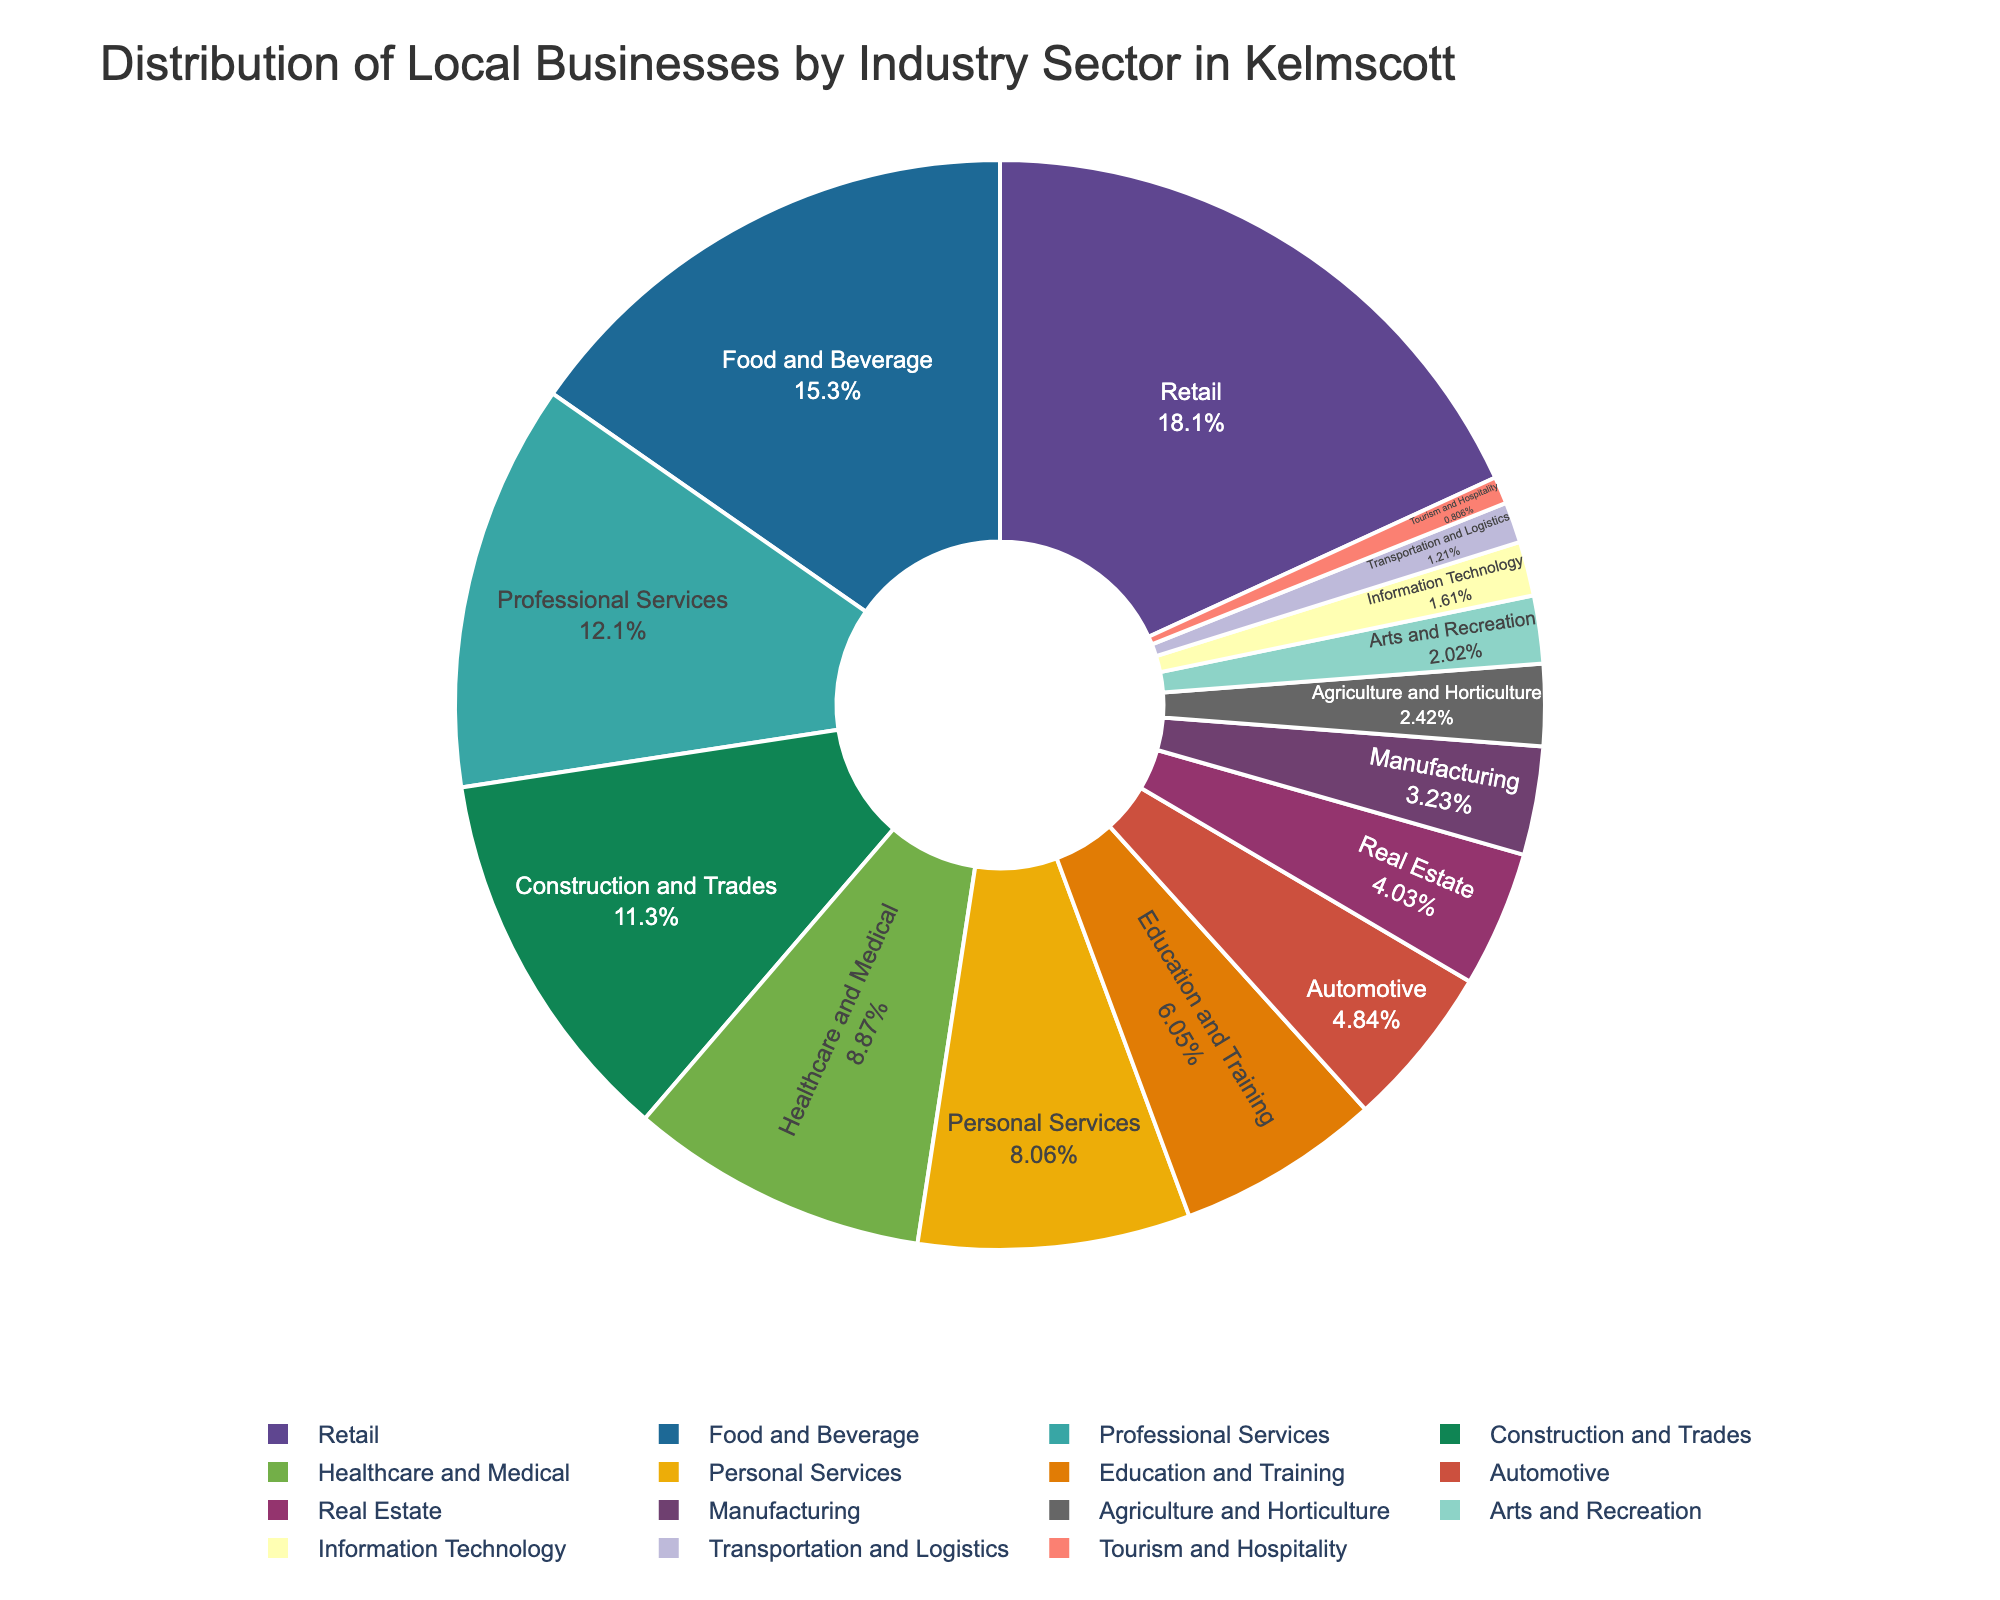What's the most common industry sector for local businesses in Kelmscott? Looking at the pie chart, we can see which sector occupies the largest portion. "Retail" is visually the largest segment.
Answer: Retail Which industry sector has fewer businesses: Automotive or Healthcare and Medical? We compare the sizes of the segments labeled "Automotive" and "Healthcare and Medical". "Automotive" has a smaller segment compared to "Healthcare and Medical".
Answer: Automotive What percentage of businesses are in the Professional Services sector compared to the total number of businesses? To find this percentage, we locate the "Professional Services" segment and check its percentage label on the pie chart.
Answer: The percentage label for "Professional Services" will provide the exact figure How many more businesses are in the Food and Beverage sector compared to the Information Technology sector? We find the number of businesses in both "Food and Beverage" (38) and "Information Technology" (4) sectors and subtract the smaller number from the larger one: 38 - 4.
Answer: 34 Is the number of businesses in Real Estate greater than, less than, or equal to the number of businesses in Automotive? We compare the segments labeled "Real Estate" and "Automotive". Real Estate (10) is less than Automotive (12).
Answer: Less than What is the total number of businesses in Education and Training, Personal Services, and Manufacturing sectors combined? Add the number of businesses in each sector: Education and Training (15) + Personal Services (20) + Manufacturing (8) = 43.
Answer: 43 Which industry sector has the least number of businesses? The smallest segment in the pie chart represents the sector with the least number of businesses, and "Tourism and Hospitality" is the smallest.
Answer: Tourism and Hospitality How does the number of businesses in Healthcare and Medical compare to those in Construction and Trades? We compare the segments for "Healthcare and Medical" (22) and "Construction and Trades" (28). "Construction and Trades" has more businesses.
Answer: Construction and Trades If you combine the businesses in Retail and Automotive sectors, what percentage do they represent of the total businesses? From the pie chart, we sum the percentages of "Retail" and "Automotive" and then compare this sum to the total number of businesses. The pie chart will show the percentage value directly by summing both sectors.
Answer: The summed percentage label will provide the exact figure What is the difference in the number of businesses between the largest and smallest sectors? We identify the largest ("Retail" with 45) and smallest ("Tourism and Hospitality" with 2) sectors and subtract the smaller number from the larger one: 45 - 2.
Answer: 43 